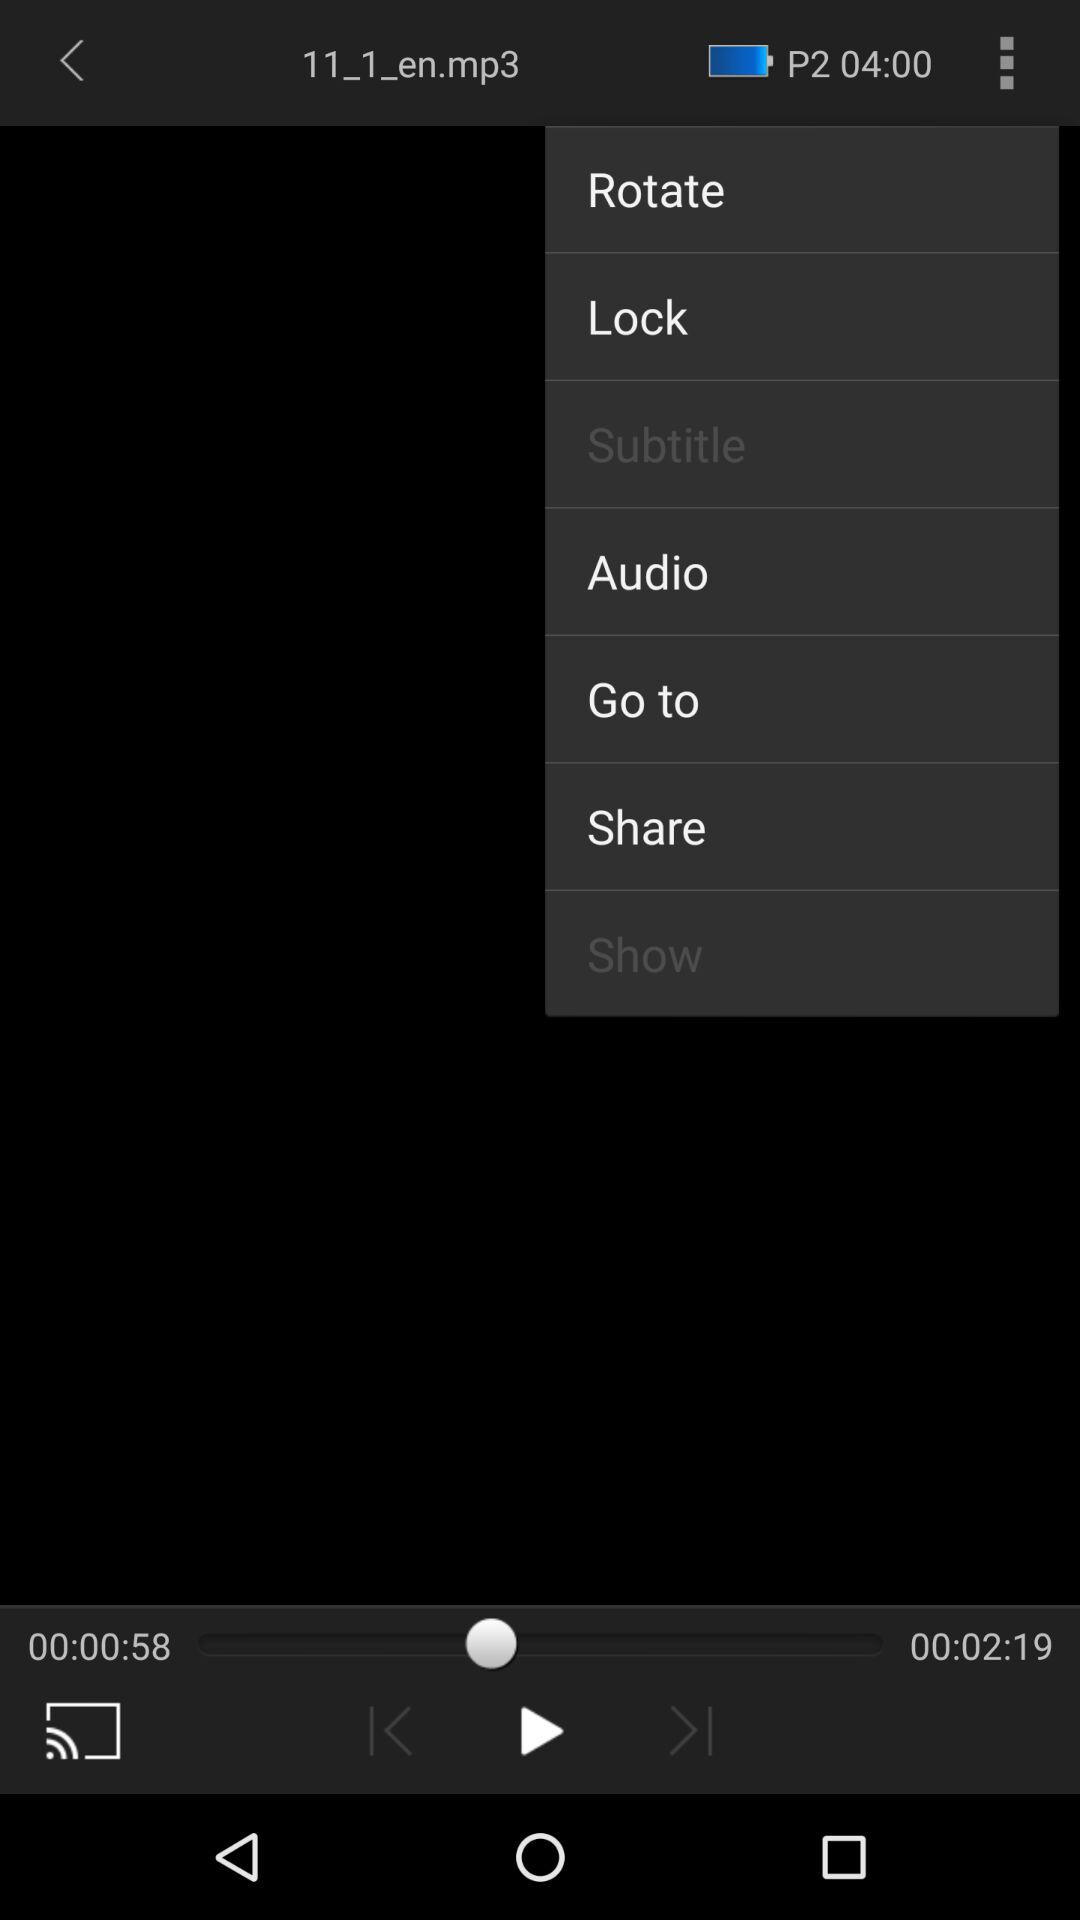What is the length of the song? The length of the song is 2 minutes 19 seconds. 